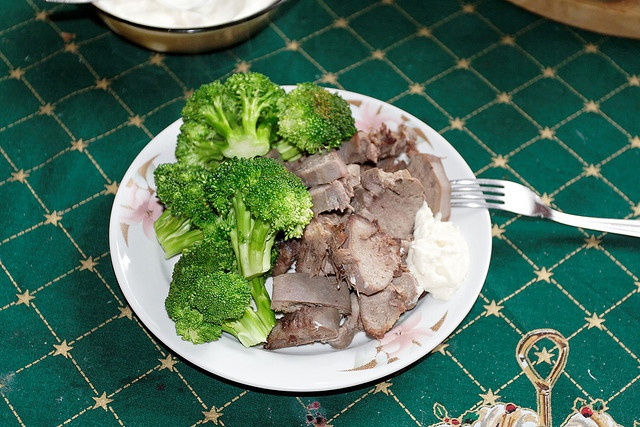Describe the objects in this image and their specific colors. I can see dining table in teal, black, darkgreen, and gray tones, bowl in teal, lightgray, darkgray, and black tones, broccoli in teal, green, darkgreen, and lightgreen tones, broccoli in teal, olive, darkgreen, green, and lightgreen tones, and broccoli in teal, darkgreen, and green tones in this image. 